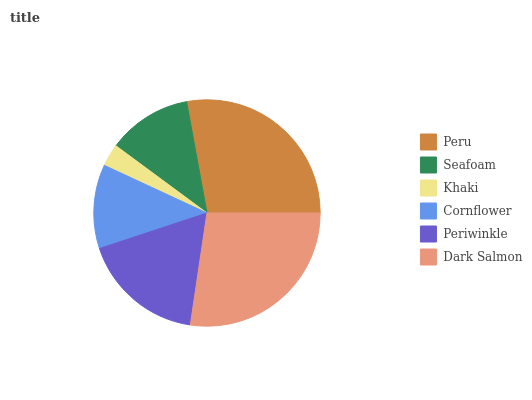Is Khaki the minimum?
Answer yes or no. Yes. Is Peru the maximum?
Answer yes or no. Yes. Is Seafoam the minimum?
Answer yes or no. No. Is Seafoam the maximum?
Answer yes or no. No. Is Peru greater than Seafoam?
Answer yes or no. Yes. Is Seafoam less than Peru?
Answer yes or no. Yes. Is Seafoam greater than Peru?
Answer yes or no. No. Is Peru less than Seafoam?
Answer yes or no. No. Is Periwinkle the high median?
Answer yes or no. Yes. Is Seafoam the low median?
Answer yes or no. Yes. Is Cornflower the high median?
Answer yes or no. No. Is Peru the low median?
Answer yes or no. No. 